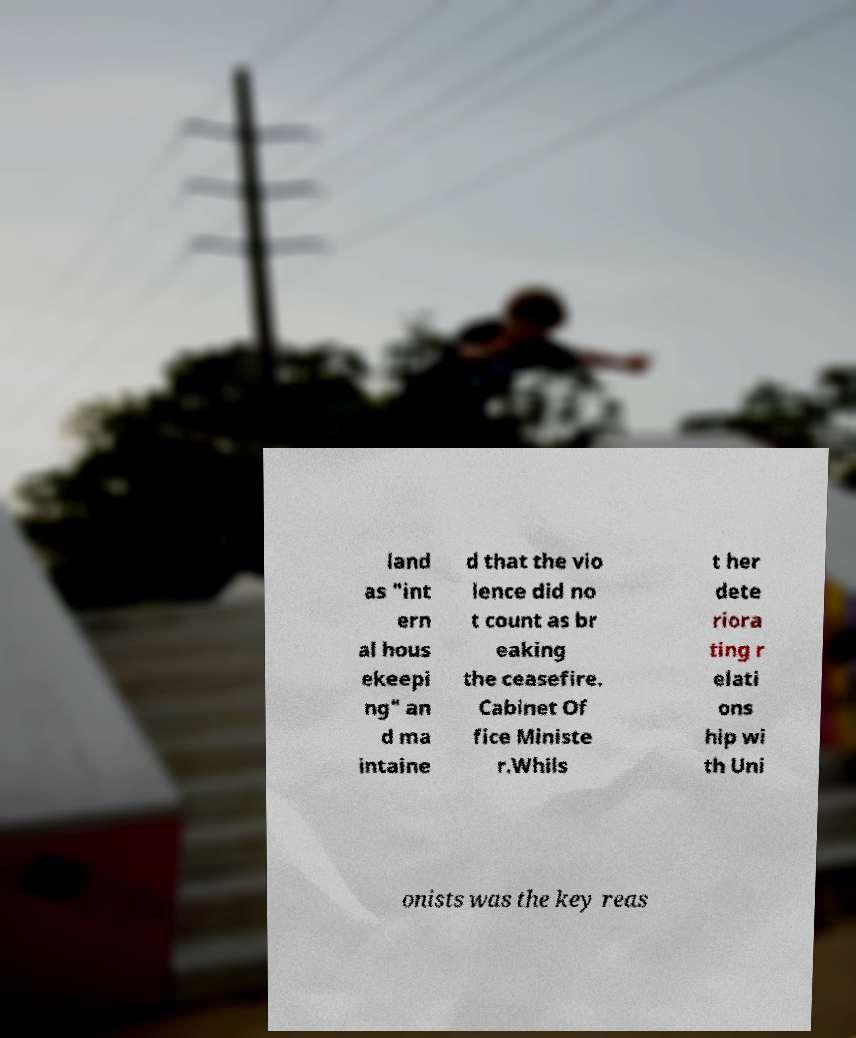For documentation purposes, I need the text within this image transcribed. Could you provide that? land as "int ern al hous ekeepi ng" an d ma intaine d that the vio lence did no t count as br eaking the ceasefire. Cabinet Of fice Ministe r.Whils t her dete riora ting r elati ons hip wi th Uni onists was the key reas 